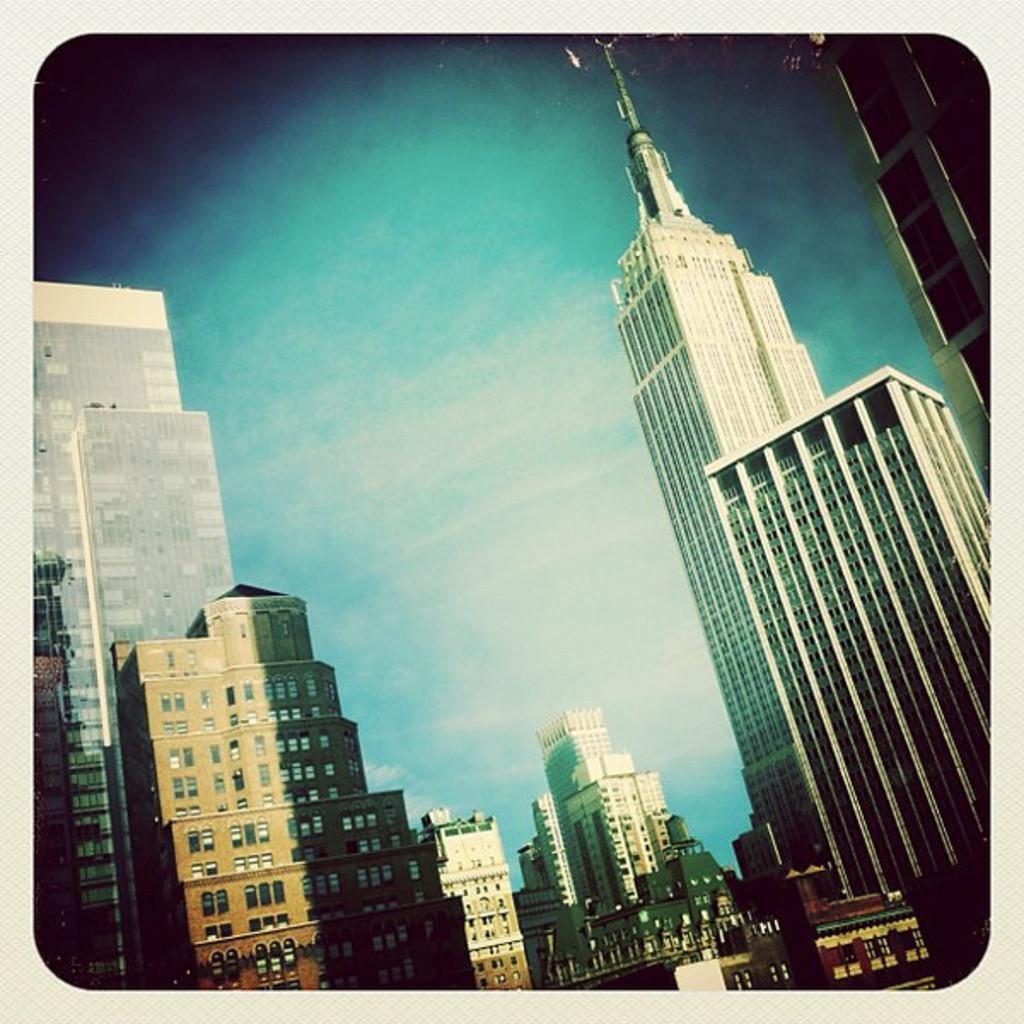What type of structures are present in the image? There are buildings in the image. What architectural feature can be seen on the buildings? Windows are visible in the image. What is the color of the sky in the image? The sky is blue and white in color. What type of example can be seen being cast in metal in the image? There is no example being cast in metal present in the image. 